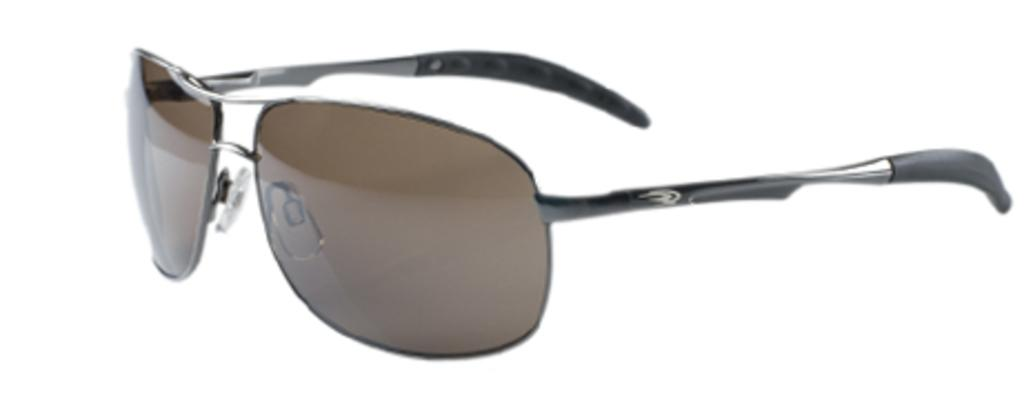What type of object is present in the image? There are shades in the image. What colors are the shades? The shades are brown, silver, and black in color. What color is the background of the image? The background of the image is white. What is the price of the yam in the image? There is no yam present in the image, so it is not possible to determine its price. 